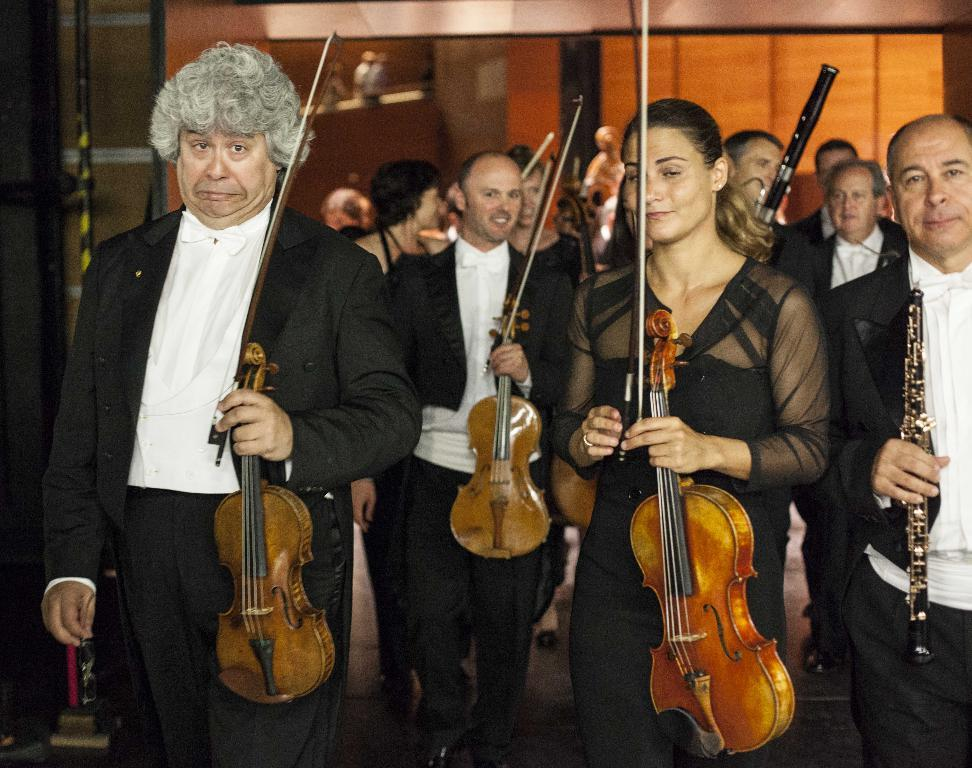What is happening in the image? There is a group of people in the image, and they are standing and holding musical instruments. How many people are holding a violin? Three persons are holding a violin. What can be seen behind the group of people? There is a brown wall at the back side of the image. What are the people writing on the head of the violin in the image? There is no indication in the image that the people are writing on the head of the violin, nor is there any visible writing. 